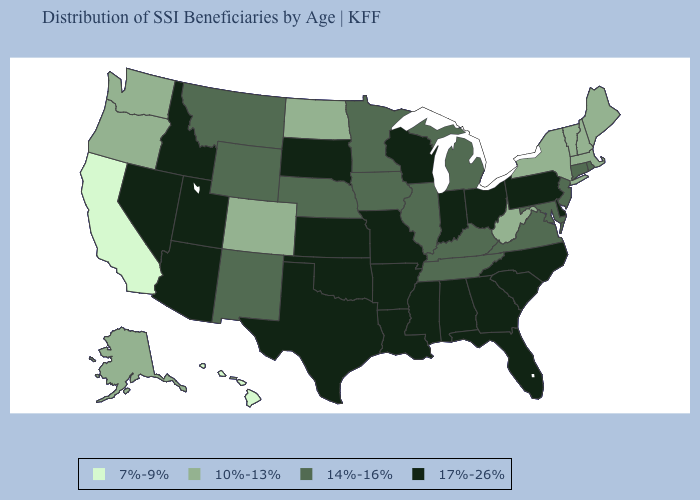Name the states that have a value in the range 17%-26%?
Give a very brief answer. Alabama, Arizona, Arkansas, Delaware, Florida, Georgia, Idaho, Indiana, Kansas, Louisiana, Mississippi, Missouri, Nevada, North Carolina, Ohio, Oklahoma, Pennsylvania, South Carolina, South Dakota, Texas, Utah, Wisconsin. Among the states that border South Carolina , which have the lowest value?
Answer briefly. Georgia, North Carolina. Which states have the lowest value in the USA?
Concise answer only. California, Hawaii. Name the states that have a value in the range 17%-26%?
Be succinct. Alabama, Arizona, Arkansas, Delaware, Florida, Georgia, Idaho, Indiana, Kansas, Louisiana, Mississippi, Missouri, Nevada, North Carolina, Ohio, Oklahoma, Pennsylvania, South Carolina, South Dakota, Texas, Utah, Wisconsin. Which states have the lowest value in the Northeast?
Give a very brief answer. Maine, Massachusetts, New Hampshire, New York, Vermont. Does Idaho have a higher value than Wisconsin?
Concise answer only. No. Does Connecticut have the highest value in the Northeast?
Concise answer only. No. What is the lowest value in the West?
Keep it brief. 7%-9%. What is the lowest value in the South?
Keep it brief. 10%-13%. Does Maine have a higher value than Wisconsin?
Keep it brief. No. What is the value of Montana?
Be succinct. 14%-16%. Name the states that have a value in the range 10%-13%?
Keep it brief. Alaska, Colorado, Maine, Massachusetts, New Hampshire, New York, North Dakota, Oregon, Vermont, Washington, West Virginia. What is the highest value in states that border Massachusetts?
Answer briefly. 14%-16%. What is the value of South Carolina?
Give a very brief answer. 17%-26%. 